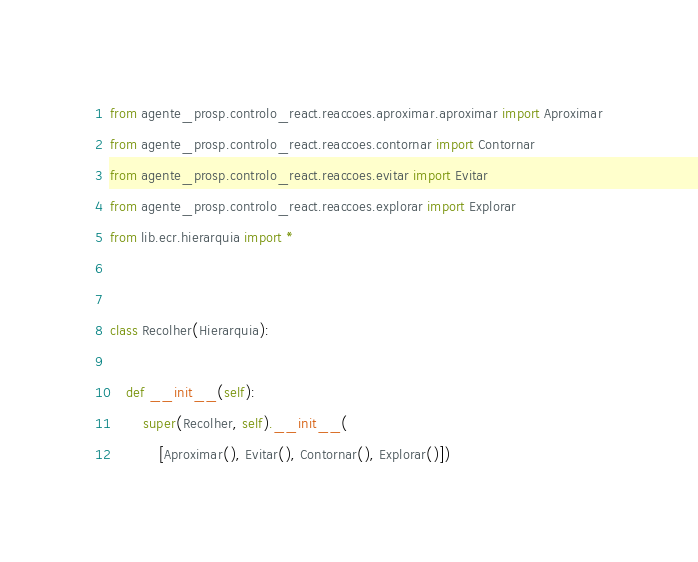<code> <loc_0><loc_0><loc_500><loc_500><_Python_>from agente_prosp.controlo_react.reaccoes.aproximar.aproximar import Aproximar
from agente_prosp.controlo_react.reaccoes.contornar import Contornar
from agente_prosp.controlo_react.reaccoes.evitar import Evitar
from agente_prosp.controlo_react.reaccoes.explorar import Explorar
from lib.ecr.hierarquia import *


class Recolher(Hierarquia):

    def __init__(self):
        super(Recolher, self).__init__(
            [Aproximar(), Evitar(), Contornar(), Explorar()])
</code> 